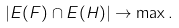<formula> <loc_0><loc_0><loc_500><loc_500>| E ( F ) \cap E ( H ) | \rightarrow \max .</formula> 